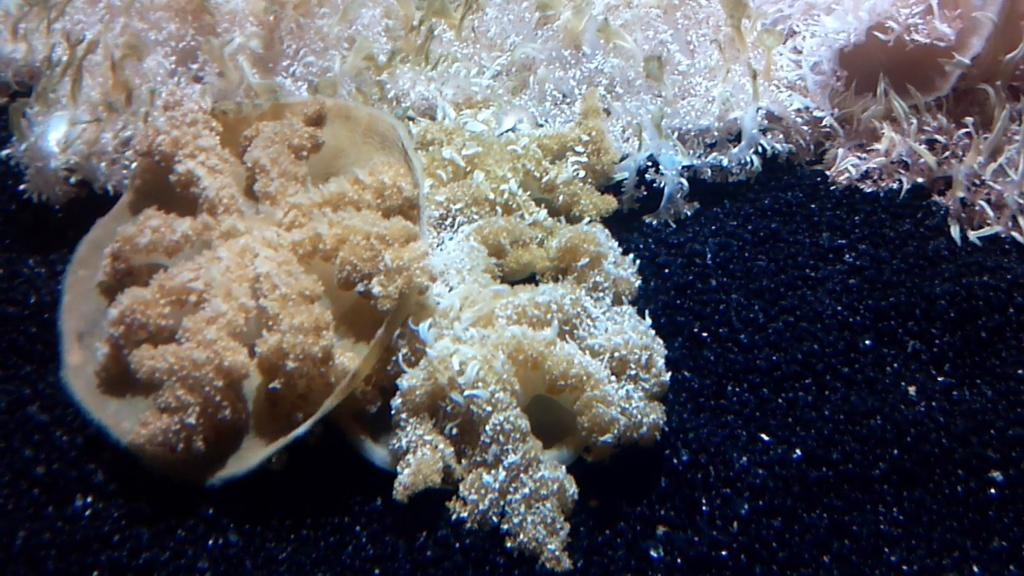What type of organism can be seen in the image? There is fungus in the image. What other object is present in the image? There is a shell in the image. What type of love can be seen growing on the pancake in the image? There is no pancake or love present in the image; it features fungus and a shell. 